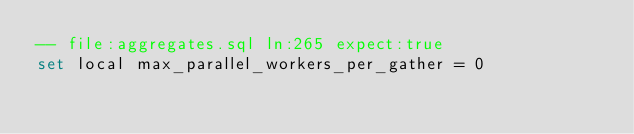Convert code to text. <code><loc_0><loc_0><loc_500><loc_500><_SQL_>-- file:aggregates.sql ln:265 expect:true
set local max_parallel_workers_per_gather = 0
</code> 